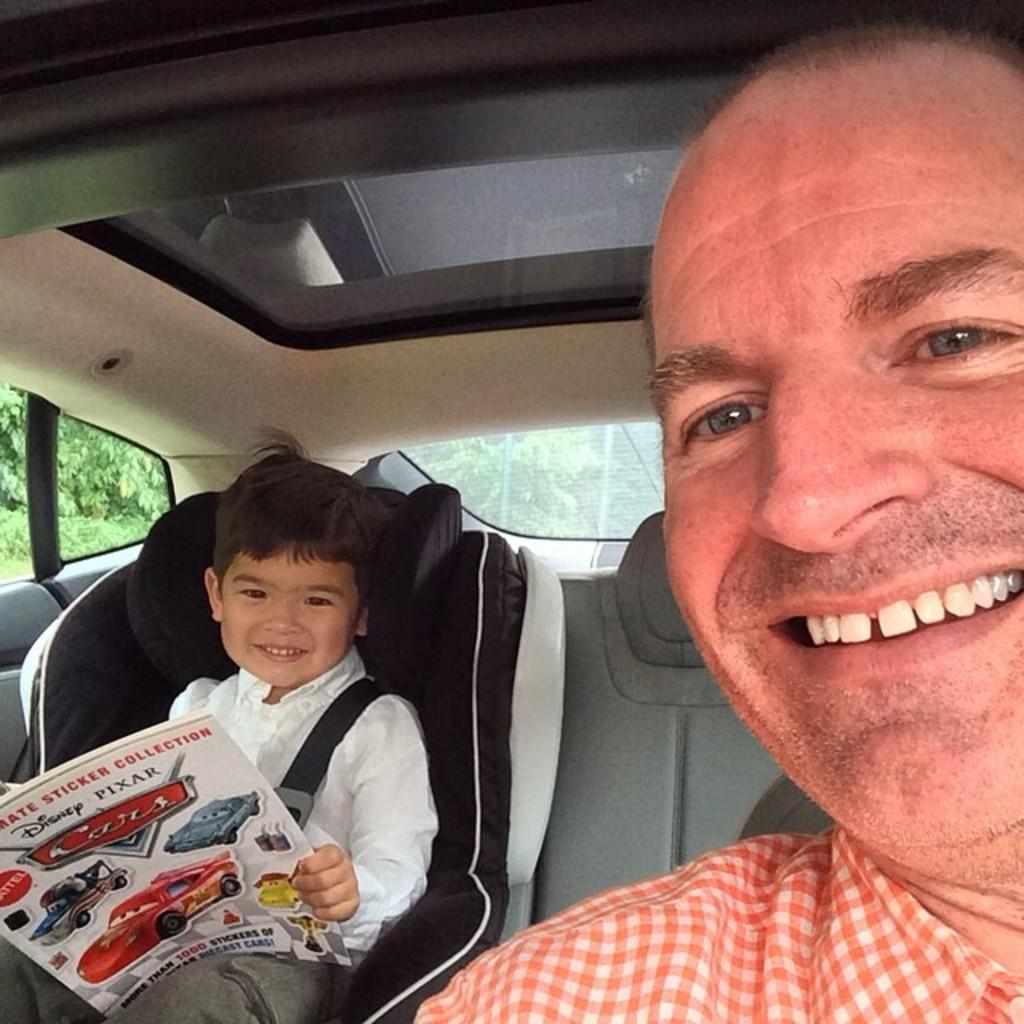Who is present in the image? There is a man and a boy in the image. What is the man doing in the image? The man is sitting in a car. Where is the boy located in the image? The boy is in the backseat of the car. How many goldfish are swimming in the car's backseat in the image? There are no goldfish present in the image. How long does it take for the sock to disappear from the image? There is no sock present in the image, so it cannot disappear or have a duration. 